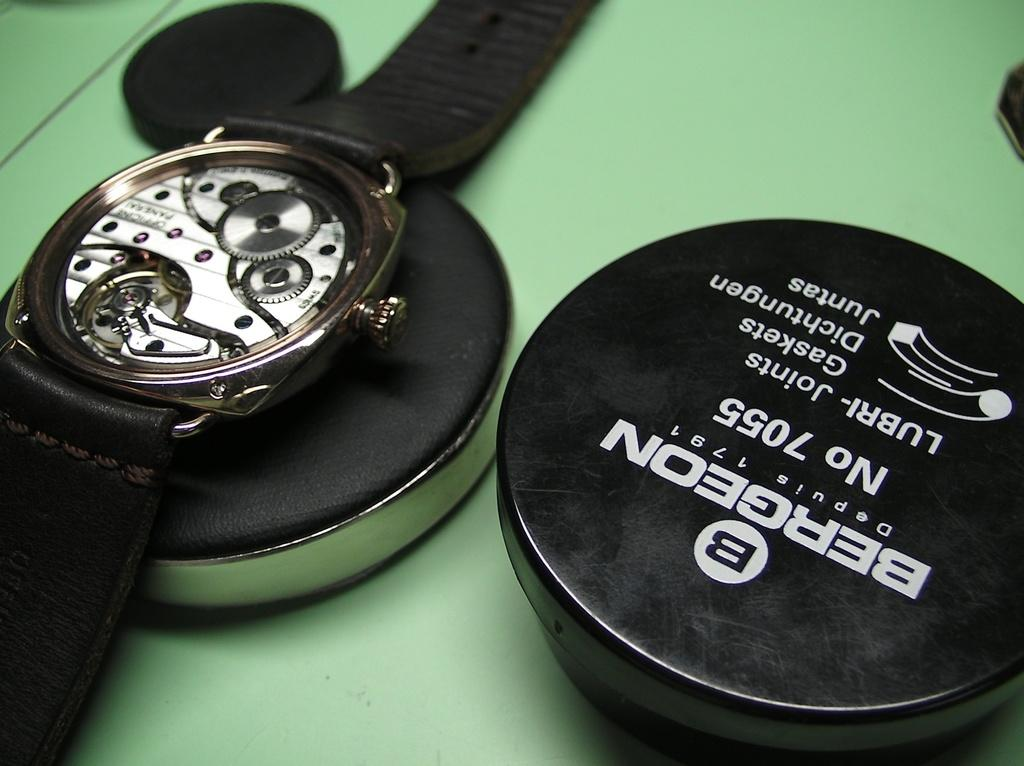<image>
Relay a brief, clear account of the picture shown. Bergeon is being used to lubricate a watch without a face. 